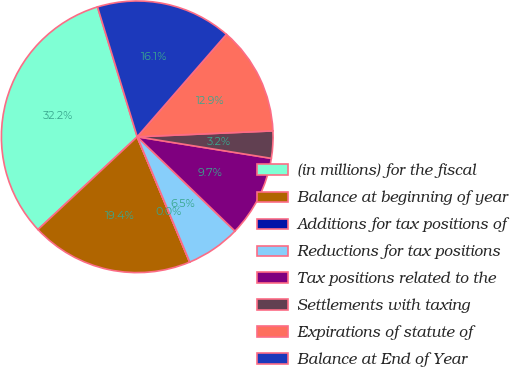Convert chart. <chart><loc_0><loc_0><loc_500><loc_500><pie_chart><fcel>(in millions) for the fiscal<fcel>Balance at beginning of year<fcel>Additions for tax positions of<fcel>Reductions for tax positions<fcel>Tax positions related to the<fcel>Settlements with taxing<fcel>Expirations of statute of<fcel>Balance at End of Year<nl><fcel>32.24%<fcel>19.35%<fcel>0.01%<fcel>6.46%<fcel>9.68%<fcel>3.23%<fcel>12.9%<fcel>16.13%<nl></chart> 